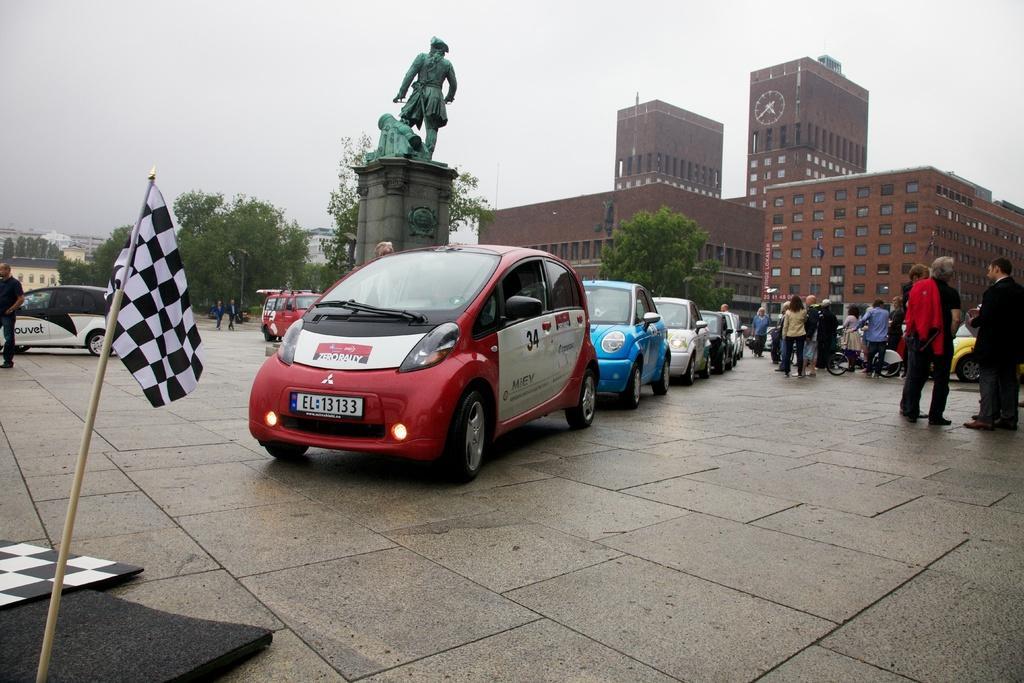Can you describe this image briefly? In this image, we can see people, vehicles and there is a statue. In the background, there are buildings, trees, poles and we can see a flag. At the bottom, we can see some black objects on the road. At the top, there is sky. 